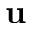Convert formula to latex. <formula><loc_0><loc_0><loc_500><loc_500>u</formula> 